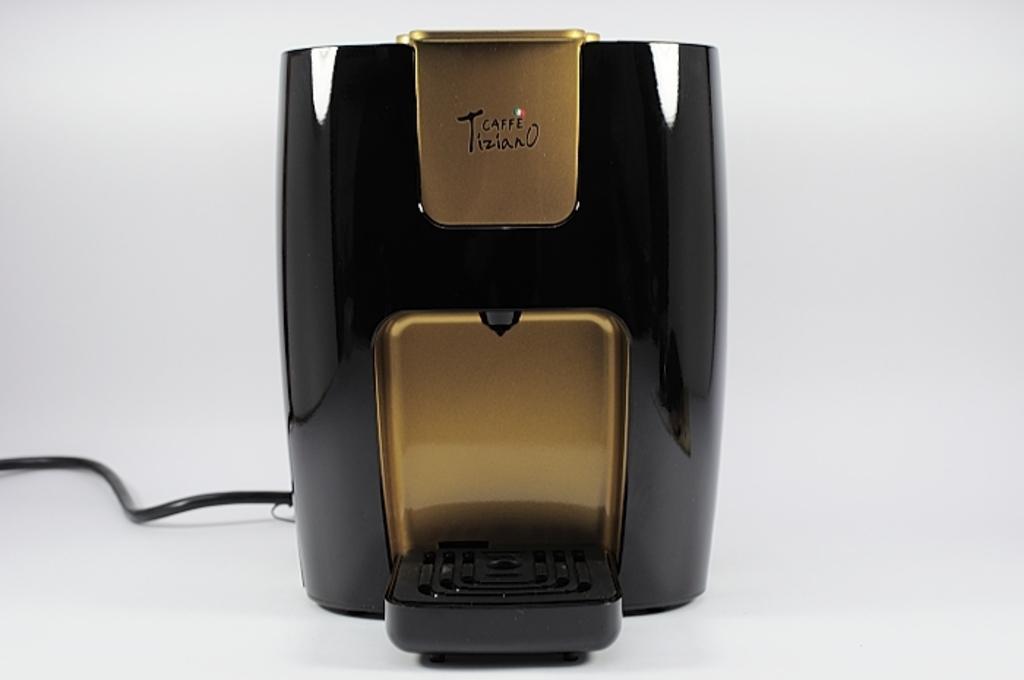Please provide a concise description of this image. In this image we can see a drip coffee maker with a wire which is placed on the surface. 